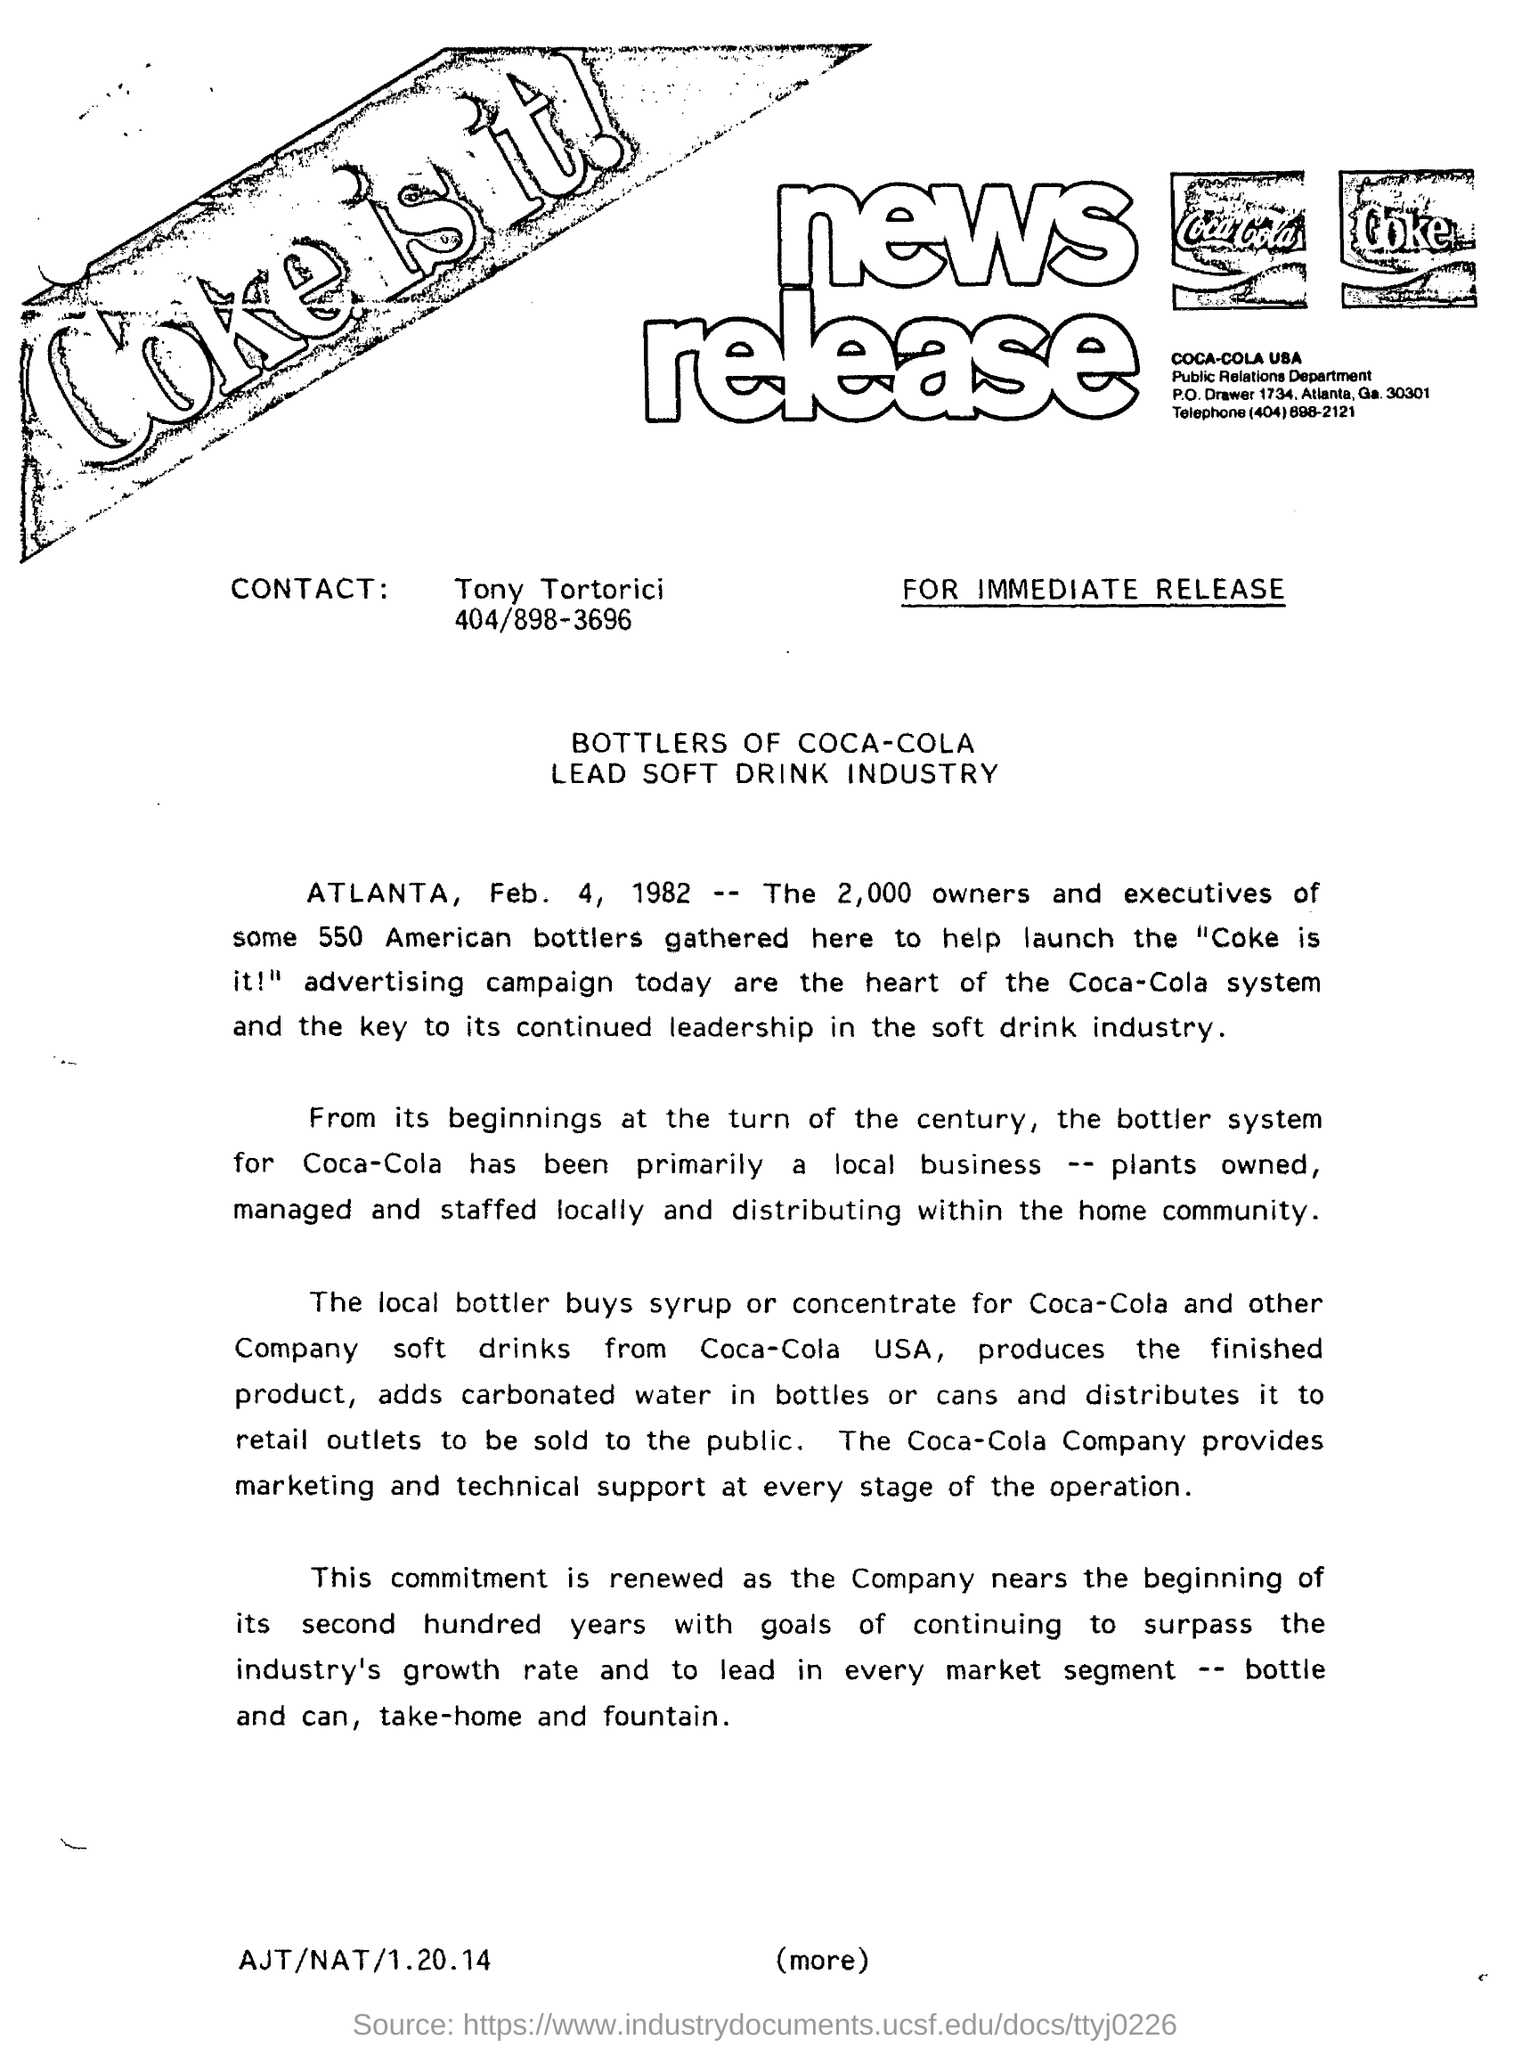Who is the contact person given in the document?
Offer a terse response. Tony Tortorici. What is the contact no of Tony Tortorici?
Give a very brief answer. 404/898-3696. What is the headline of the news release?
Provide a short and direct response. BOTTLERS OF COCA-COLA LEAD SOFT DRINK INDUSTRY. Which company provides marketing and technical support at every stage of the operation?
Offer a very short reply. Coca-Cola Company. 